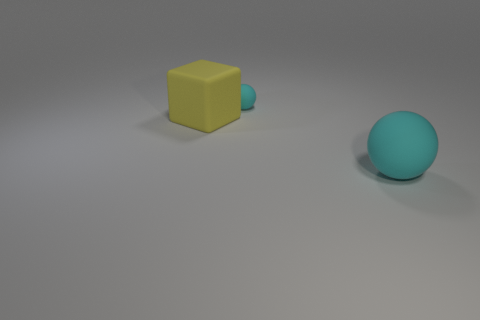Subtract all purple balls. Subtract all yellow cylinders. How many balls are left? 2 Add 3 gray objects. How many objects exist? 6 Subtract all spheres. How many objects are left? 1 Add 2 yellow matte cylinders. How many yellow matte cylinders exist? 2 Subtract 0 gray spheres. How many objects are left? 3 Subtract all green matte cylinders. Subtract all large balls. How many objects are left? 2 Add 1 yellow objects. How many yellow objects are left? 2 